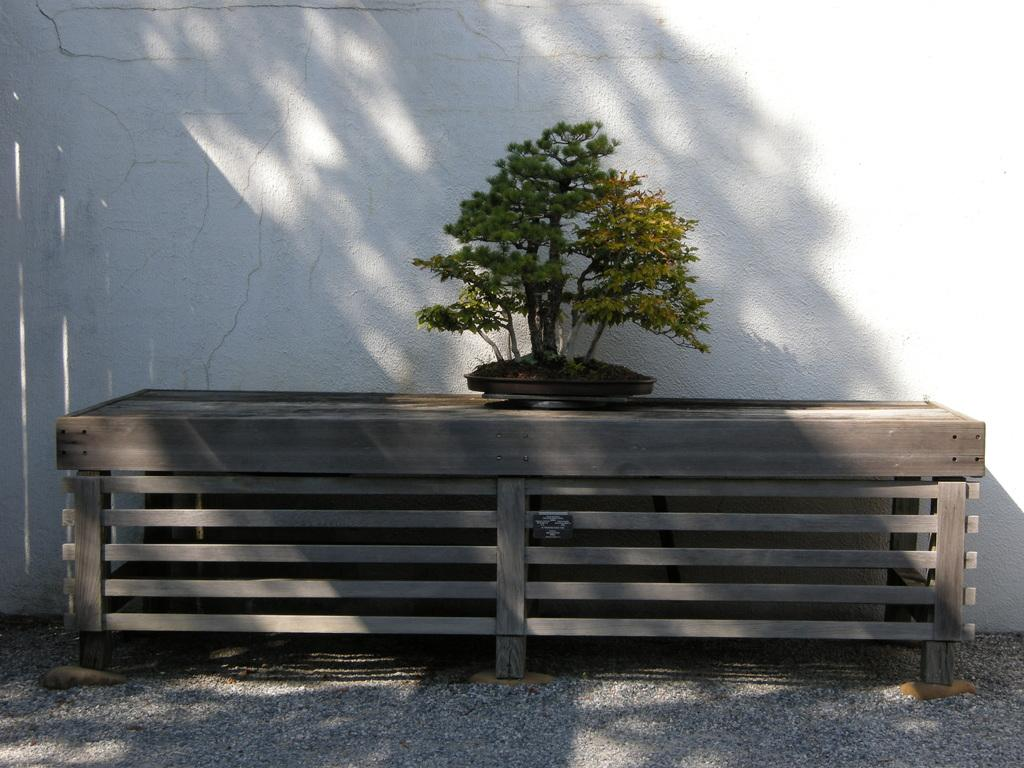What is placed on the wooden table in the image? There is a plant on a wooden table in the image. What can be seen in the background of the image? There is a wall in the image. How many turkeys can be seen in the image? There are no turkeys present in the image. What type of fish is swimming near the plant in the image? There is no fish present in the image; it features a plant on a wooden table and a wall in the background. 